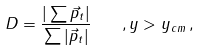Convert formula to latex. <formula><loc_0><loc_0><loc_500><loc_500>D = \frac { | \sum \vec { p } _ { t } | } { \sum | \vec { p } _ { t } | } \quad , y > y _ { c m } \, ,</formula> 